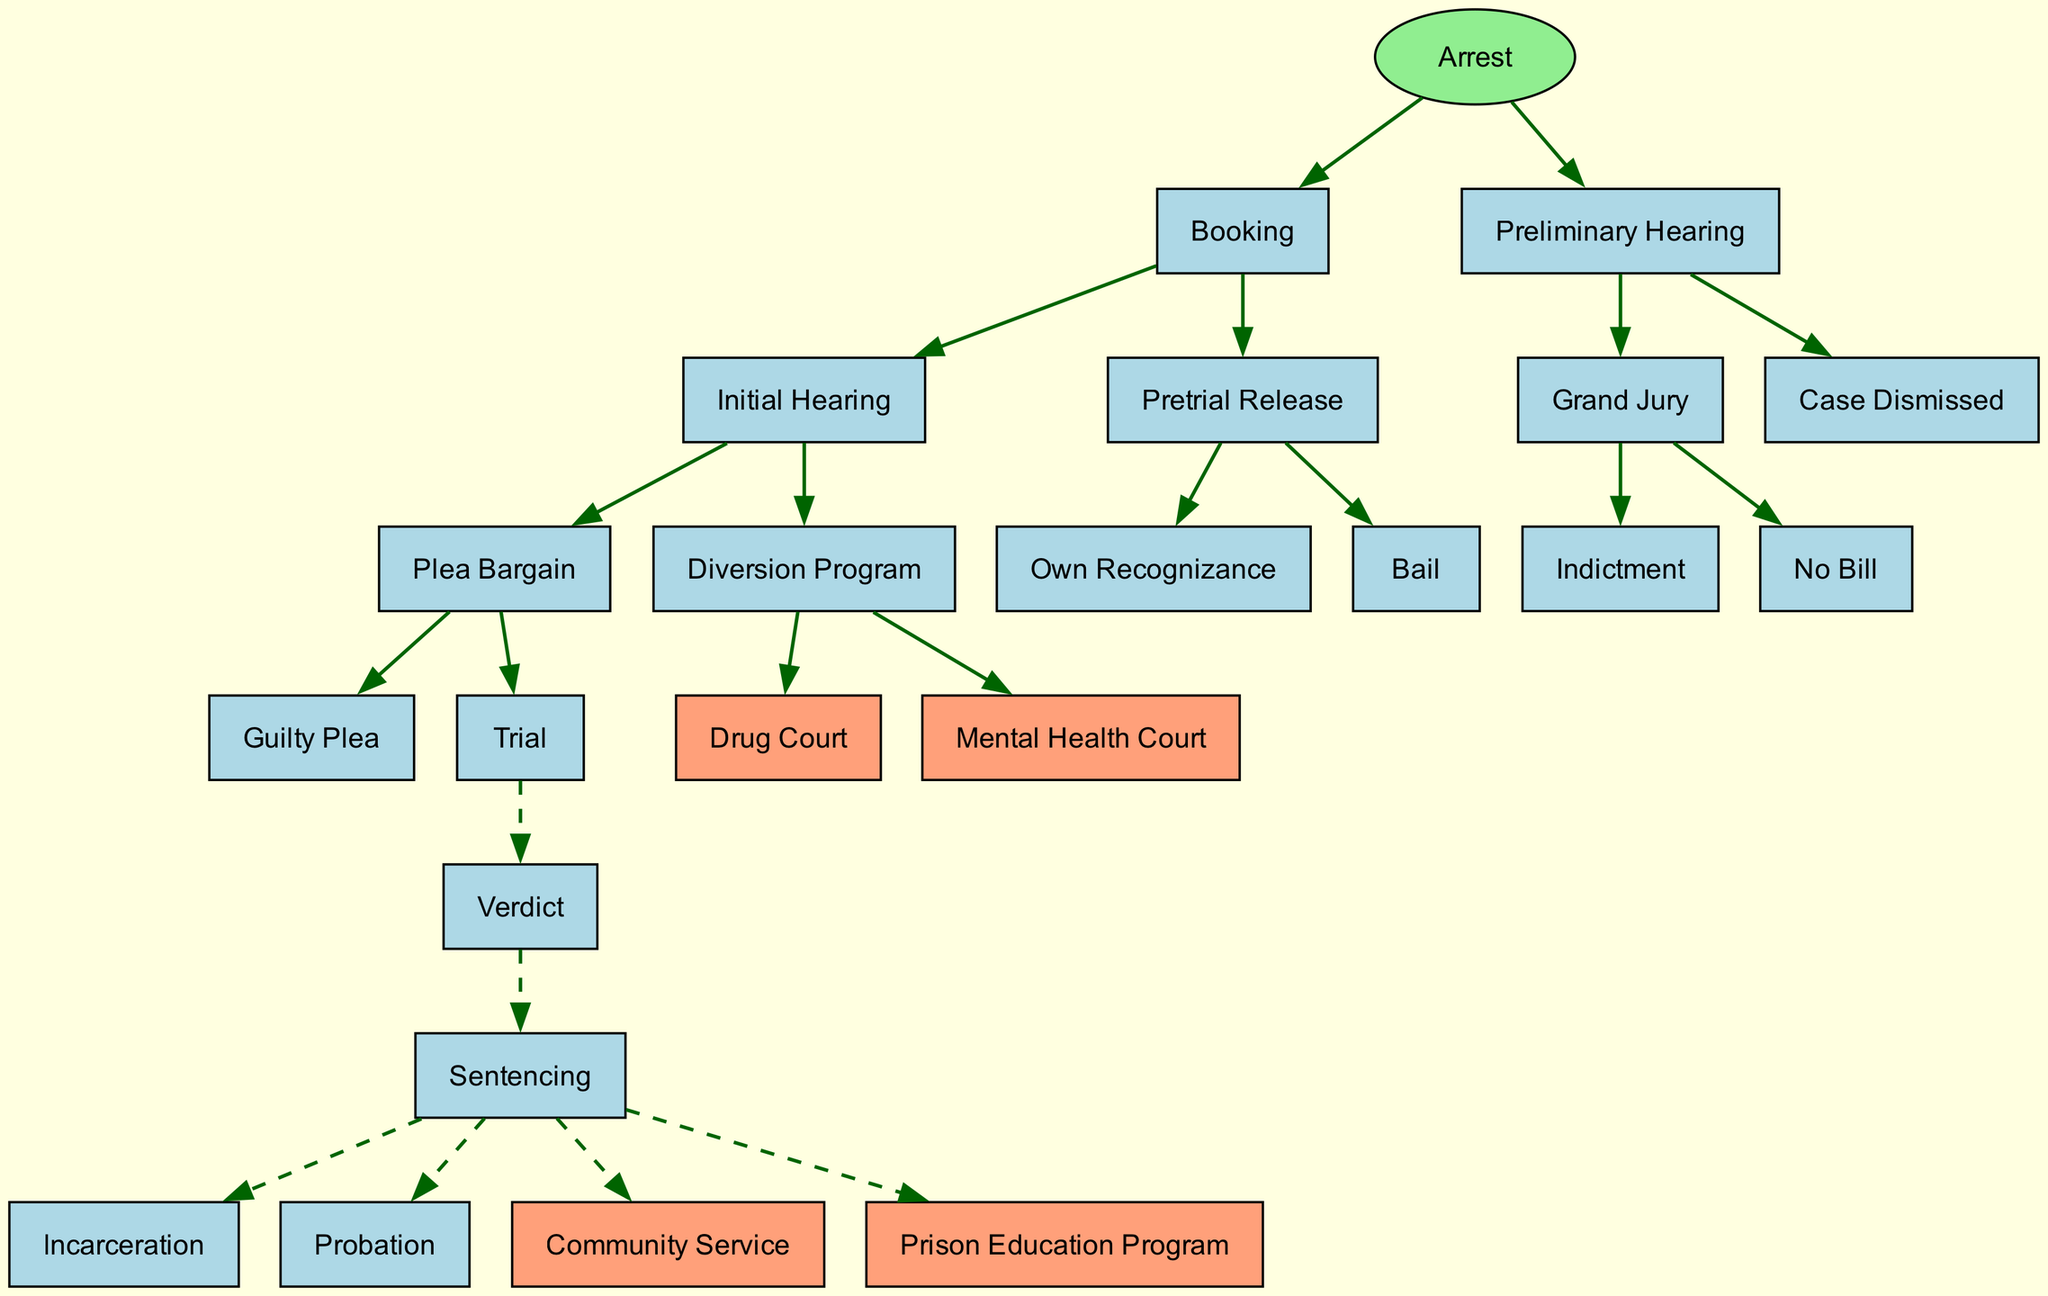What is the root node of the diagram? The root node represents the starting point of the flowchart. In this case, it is labeled "Arrest."
Answer: Arrest How many nodes are there in total in the diagram? Counting both the root node and all the subsequent nodes across different paths, there is a total of 10 nodes: Arrest, Booking, Initial Hearing, Plea Bargain, Diversion Program, Preliminary Hearing, Grand Jury, Verdict, Sentencing, and Case Dismissed.
Answer: 10 Which node follows "Trial"? The node that follows "Trial" is "Verdict". In the flow of the diagram, "Trial" is linked directly to "Verdict" as the next step.
Answer: Verdict What are the two options listed under the "Diversion Program"? The "Diversion Program" has two options listed as its children: "Drug Court" and "Mental Health Court." These represent alternative paths within the criminal justice process that aim to divert individuals from traditional prosecution.
Answer: Drug Court, Mental Health Court If "Guilty Plea" is chosen, what is the next node? The next node after "Guilty Plea" is "Sentencing." This follows the chain where choosing a plea leads to the sentencing phase in the criminal justice process.
Answer: Sentencing What types of sentencing options are available following the "Sentencing" node? The diagram lists four options available following the "Sentencing" node: "Incarceration," "Probation," "Community Service," and "Prison Education Program." Each represents a different potential outcome for the defendant.
Answer: Incarceration, Probation, Community Service, Prison Education Program What is the outcome if "No Bill" is decided in the "Grand Jury"? If "No Bill" is decided in the "Grand Jury," the outcome is "Case Dismissed." This means that the case will not proceed further in the criminal justice process.
Answer: Case Dismissed Which node is highlighted as an option emphasizing education? "Prison Education Program" is highlighted as an option emphasizing education in the context of sentencing. It is marked specifically in the diagram to indicate its focus on educational opportunities for incarcerated individuals.
Answer: Prison Education Program What are the two types of pretrial release options listed? The two types of pretrial release options listed are "Own Recognizance" and "Bail." These options represent different ways a defendant can be released from custody before trial.
Answer: Own Recognizance, Bail 